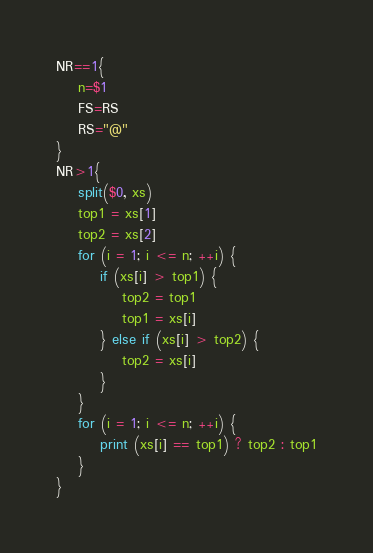Convert code to text. <code><loc_0><loc_0><loc_500><loc_500><_Awk_>NR==1{
    n=$1
    FS=RS
    RS="@"
}
NR>1{
    split($0, xs)
    top1 = xs[1]
    top2 = xs[2]
    for (i = 1; i <= n; ++i) {
        if (xs[i] > top1) {
            top2 = top1
            top1 = xs[i]
        } else if (xs[i] > top2) {
            top2 = xs[i]
        }
    }
    for (i = 1; i <= n; ++i) {
        print (xs[i] == top1) ? top2 : top1
    }
}
</code> 